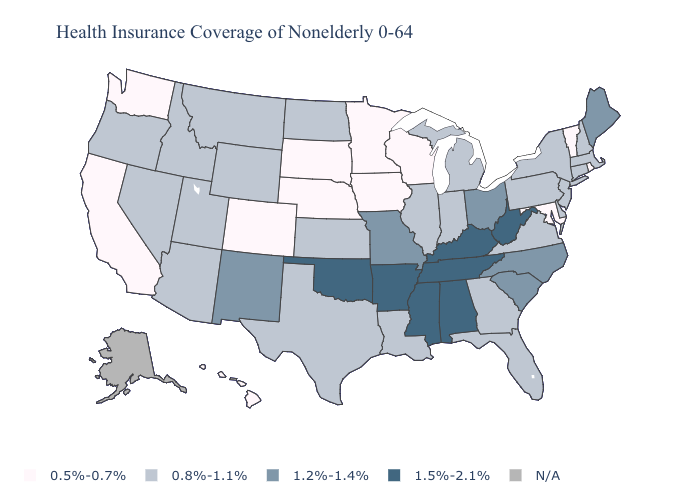Name the states that have a value in the range 1.2%-1.4%?
Answer briefly. Maine, Missouri, New Mexico, North Carolina, Ohio, South Carolina. Name the states that have a value in the range N/A?
Be succinct. Alaska. Among the states that border Kentucky , does Tennessee have the lowest value?
Quick response, please. No. What is the value of Massachusetts?
Write a very short answer. 0.8%-1.1%. What is the highest value in states that border Connecticut?
Short answer required. 0.8%-1.1%. Name the states that have a value in the range 1.5%-2.1%?
Give a very brief answer. Alabama, Arkansas, Kentucky, Mississippi, Oklahoma, Tennessee, West Virginia. What is the value of Kansas?
Short answer required. 0.8%-1.1%. Which states have the lowest value in the USA?
Give a very brief answer. California, Colorado, Hawaii, Iowa, Maryland, Minnesota, Nebraska, Rhode Island, South Dakota, Vermont, Washington, Wisconsin. Name the states that have a value in the range N/A?
Short answer required. Alaska. Name the states that have a value in the range 1.5%-2.1%?
Short answer required. Alabama, Arkansas, Kentucky, Mississippi, Oklahoma, Tennessee, West Virginia. What is the value of Minnesota?
Give a very brief answer. 0.5%-0.7%. What is the value of Utah?
Write a very short answer. 0.8%-1.1%. What is the value of Iowa?
Give a very brief answer. 0.5%-0.7%. What is the highest value in states that border Washington?
Concise answer only. 0.8%-1.1%. Name the states that have a value in the range 0.8%-1.1%?
Short answer required. Arizona, Connecticut, Delaware, Florida, Georgia, Idaho, Illinois, Indiana, Kansas, Louisiana, Massachusetts, Michigan, Montana, Nevada, New Hampshire, New Jersey, New York, North Dakota, Oregon, Pennsylvania, Texas, Utah, Virginia, Wyoming. 